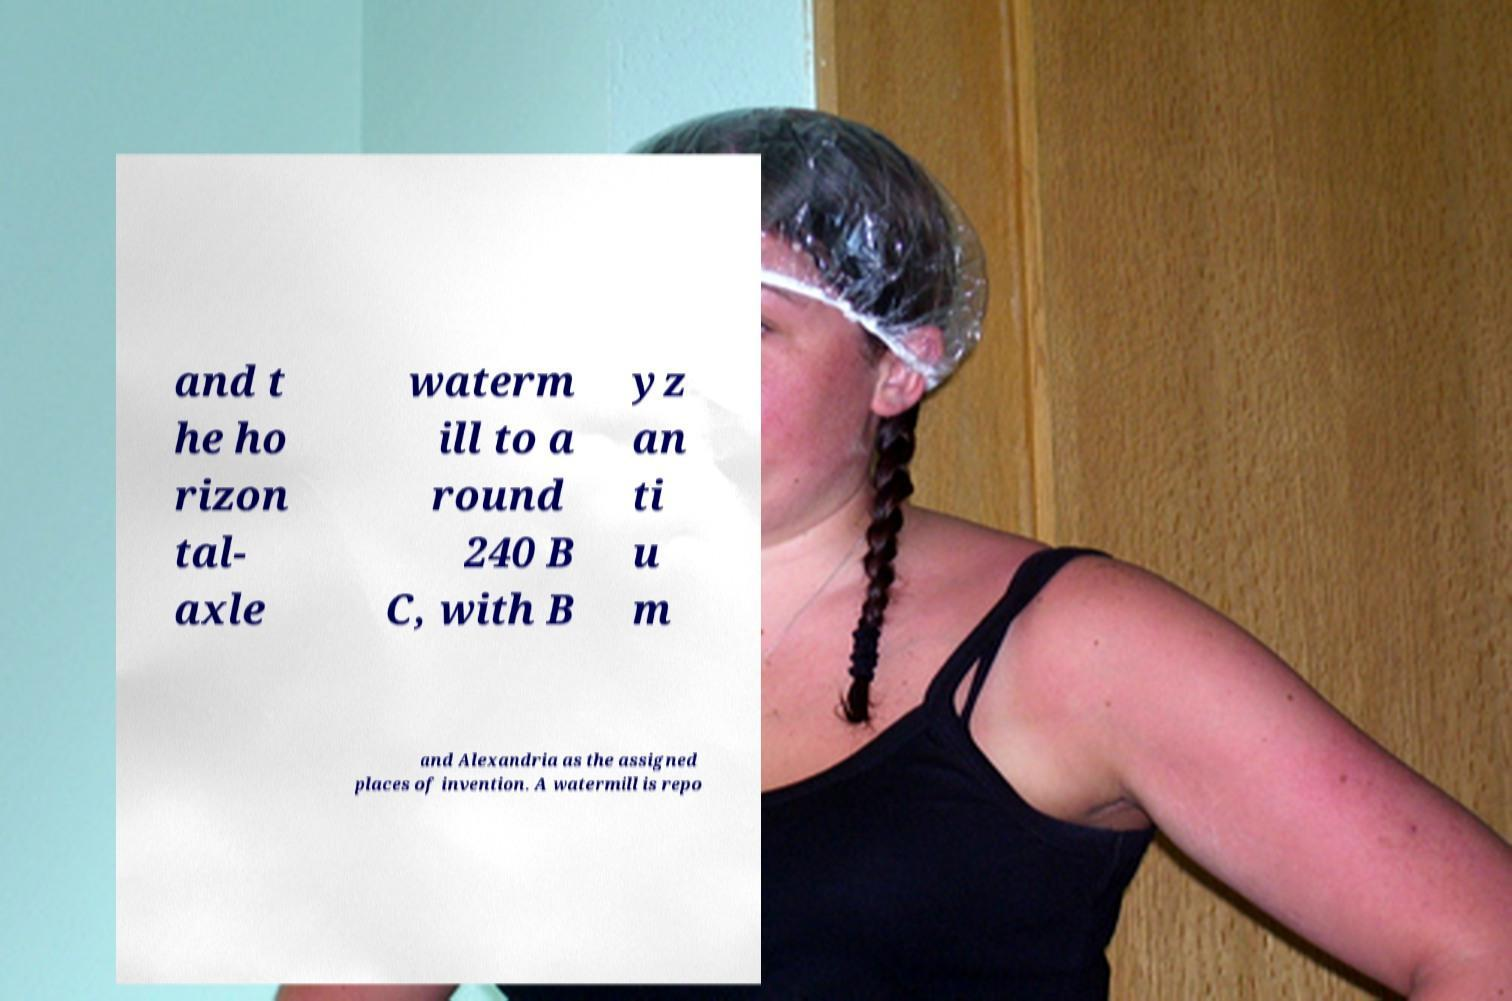Could you assist in decoding the text presented in this image and type it out clearly? and t he ho rizon tal- axle waterm ill to a round 240 B C, with B yz an ti u m and Alexandria as the assigned places of invention. A watermill is repo 